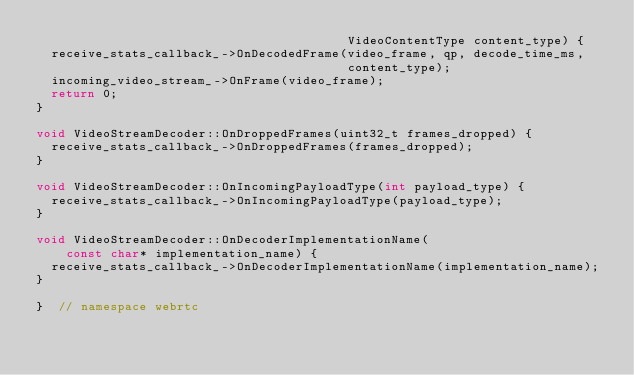Convert code to text. <code><loc_0><loc_0><loc_500><loc_500><_C++_>                                          VideoContentType content_type) {
  receive_stats_callback_->OnDecodedFrame(video_frame, qp, decode_time_ms,
                                          content_type);
  incoming_video_stream_->OnFrame(video_frame);
  return 0;
}

void VideoStreamDecoder::OnDroppedFrames(uint32_t frames_dropped) {
  receive_stats_callback_->OnDroppedFrames(frames_dropped);
}

void VideoStreamDecoder::OnIncomingPayloadType(int payload_type) {
  receive_stats_callback_->OnIncomingPayloadType(payload_type);
}

void VideoStreamDecoder::OnDecoderImplementationName(
    const char* implementation_name) {
  receive_stats_callback_->OnDecoderImplementationName(implementation_name);
}

}  // namespace webrtc
</code> 